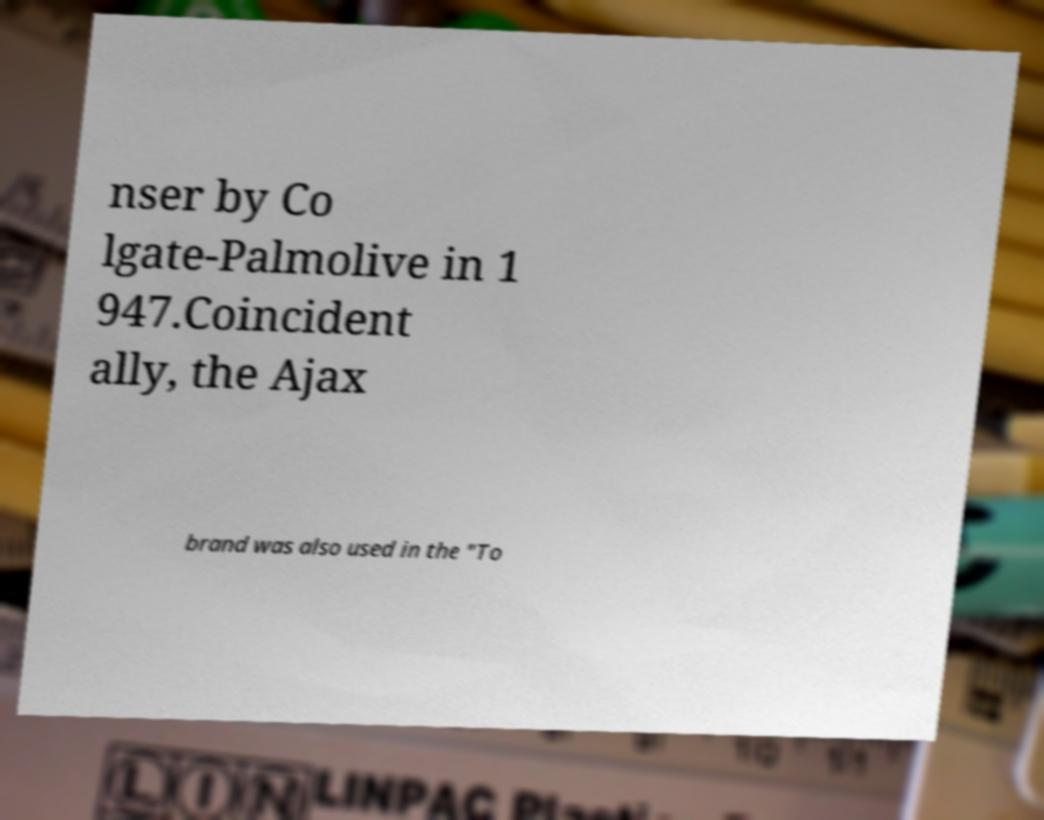For documentation purposes, I need the text within this image transcribed. Could you provide that? nser by Co lgate-Palmolive in 1 947.Coincident ally, the Ajax brand was also used in the "To 